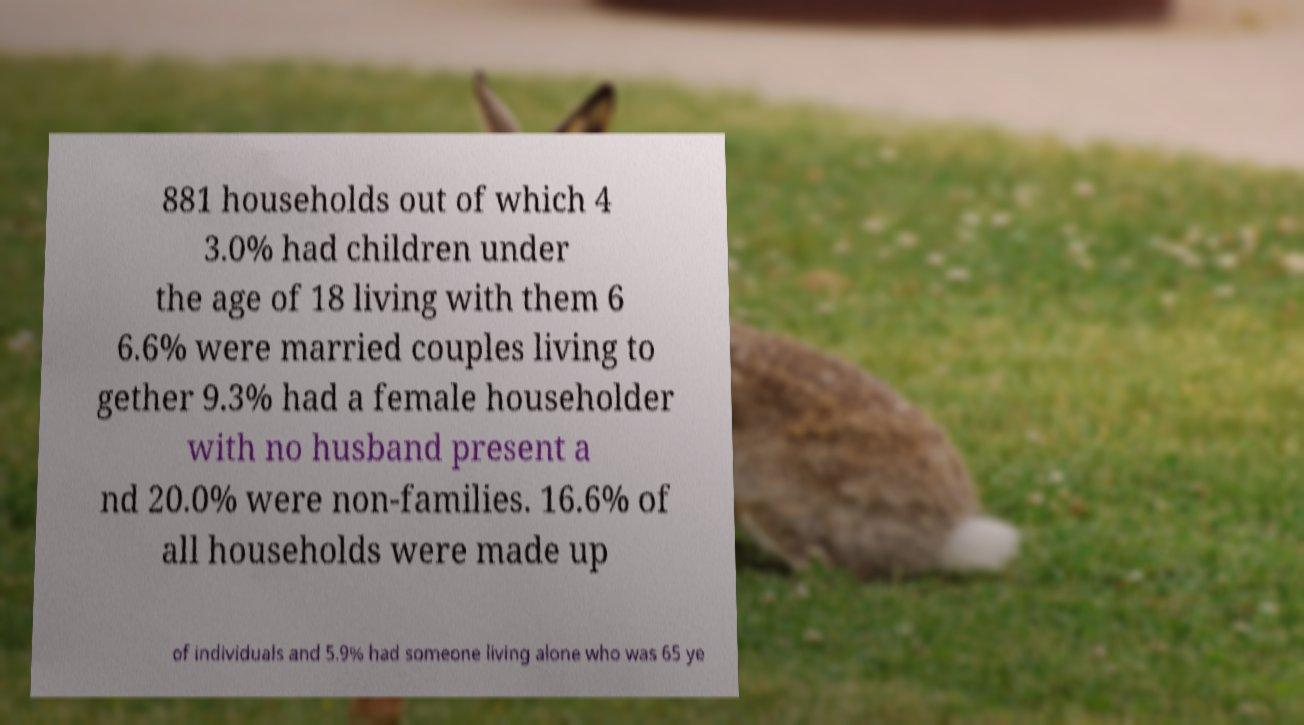For documentation purposes, I need the text within this image transcribed. Could you provide that? 881 households out of which 4 3.0% had children under the age of 18 living with them 6 6.6% were married couples living to gether 9.3% had a female householder with no husband present a nd 20.0% were non-families. 16.6% of all households were made up of individuals and 5.9% had someone living alone who was 65 ye 